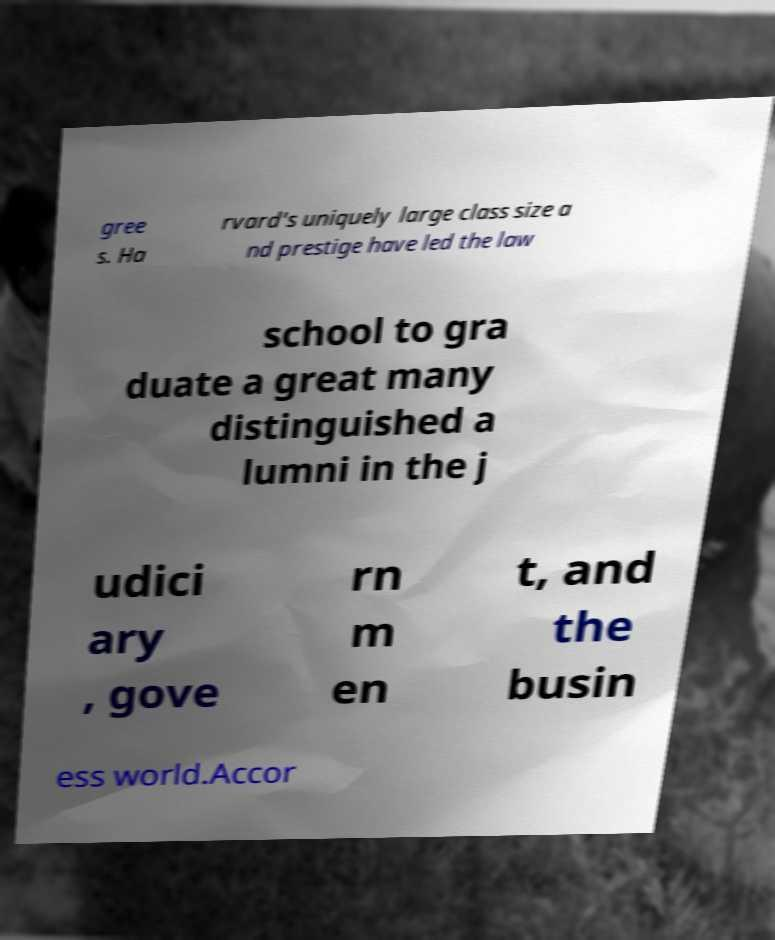There's text embedded in this image that I need extracted. Can you transcribe it verbatim? gree s. Ha rvard's uniquely large class size a nd prestige have led the law school to gra duate a great many distinguished a lumni in the j udici ary , gove rn m en t, and the busin ess world.Accor 